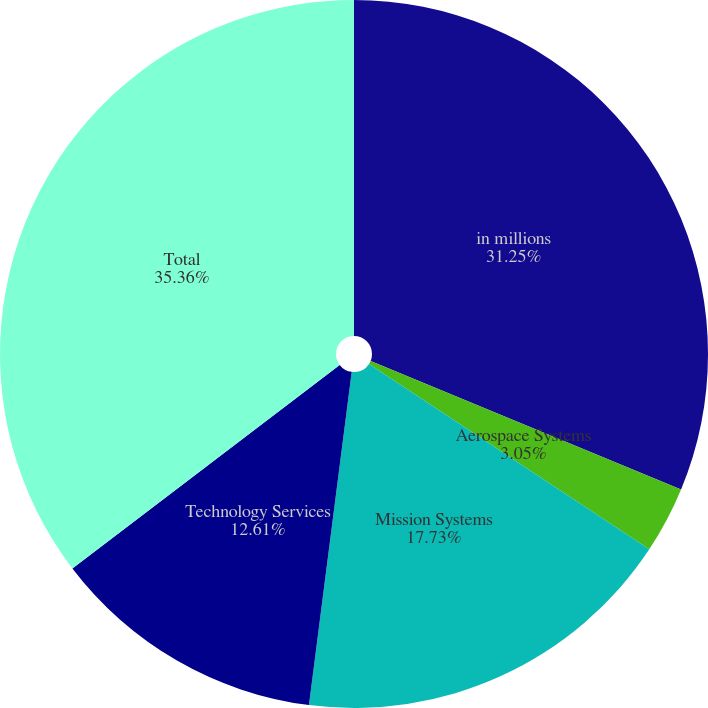<chart> <loc_0><loc_0><loc_500><loc_500><pie_chart><fcel>in millions<fcel>Aerospace Systems<fcel>Mission Systems<fcel>Technology Services<fcel>Total<nl><fcel>31.25%<fcel>3.05%<fcel>17.73%<fcel>12.61%<fcel>35.36%<nl></chart> 